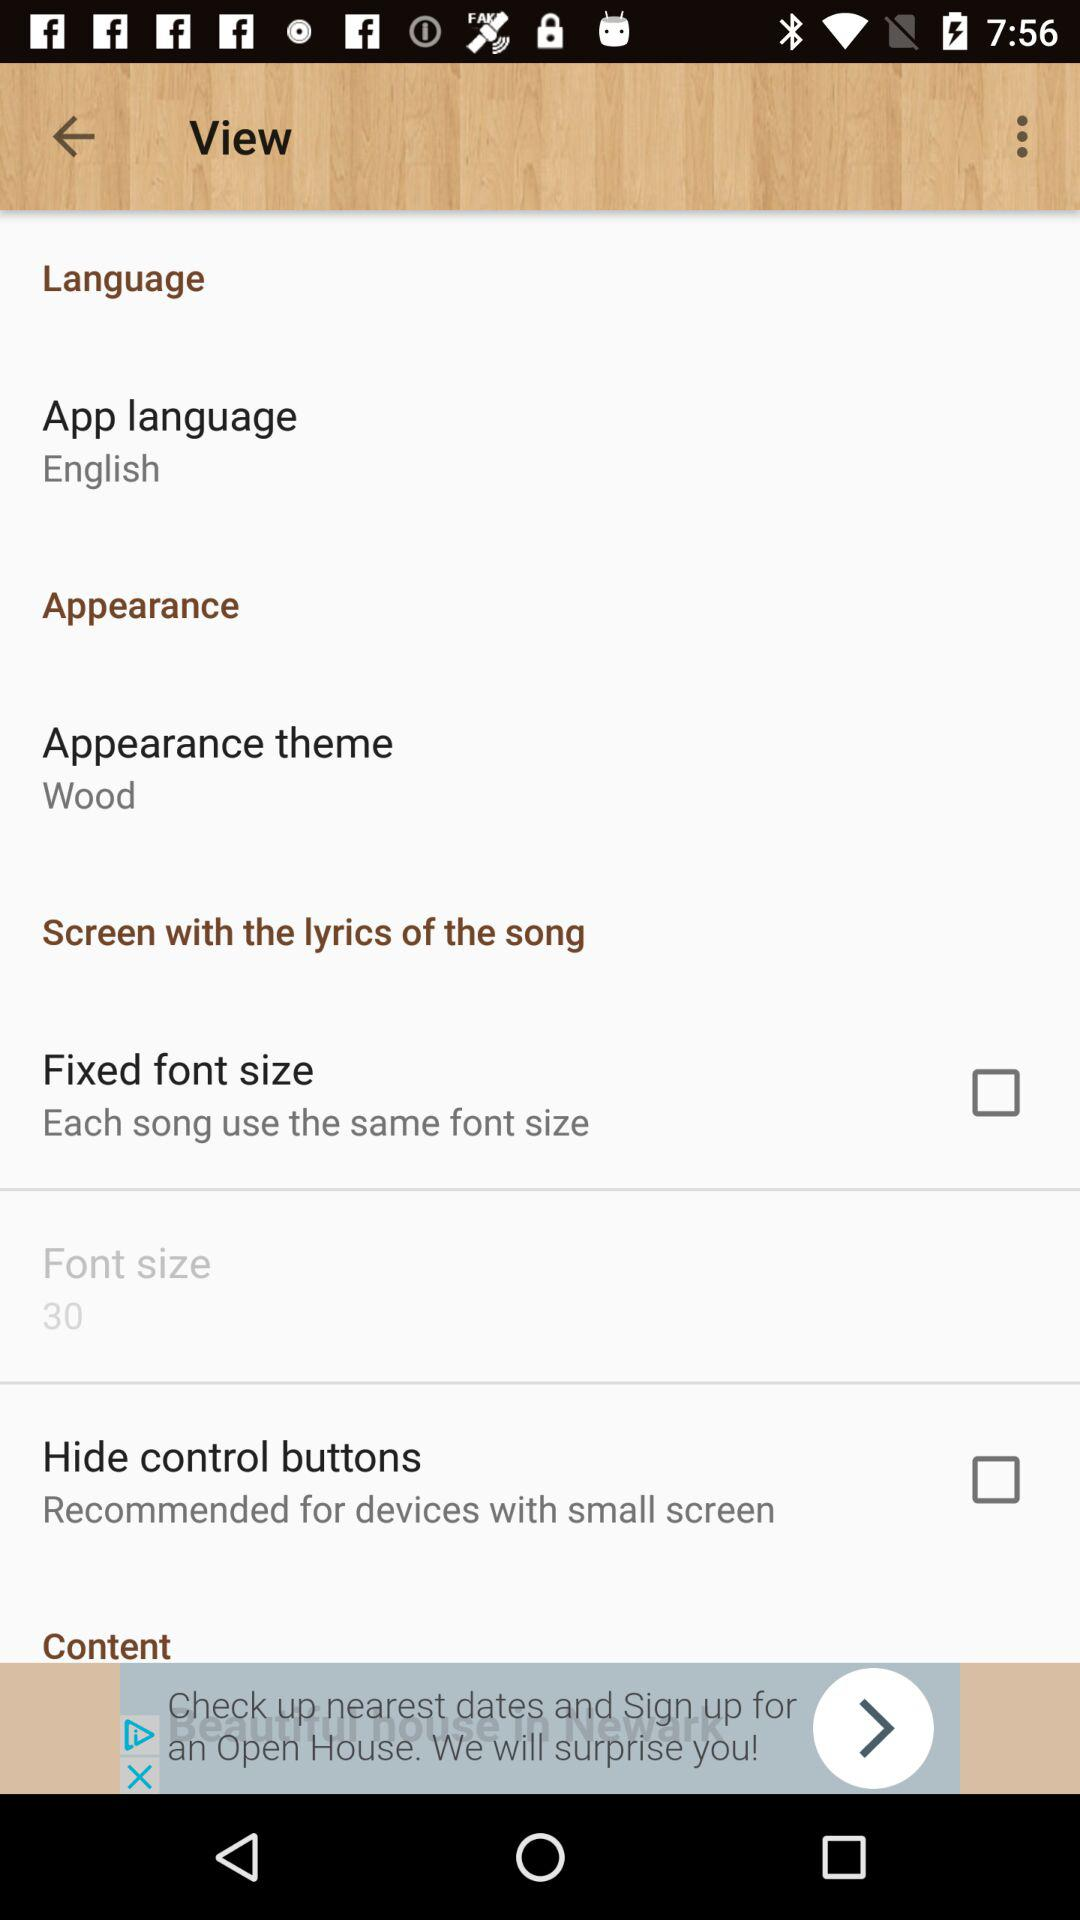What is the font size? The font size is 30. 